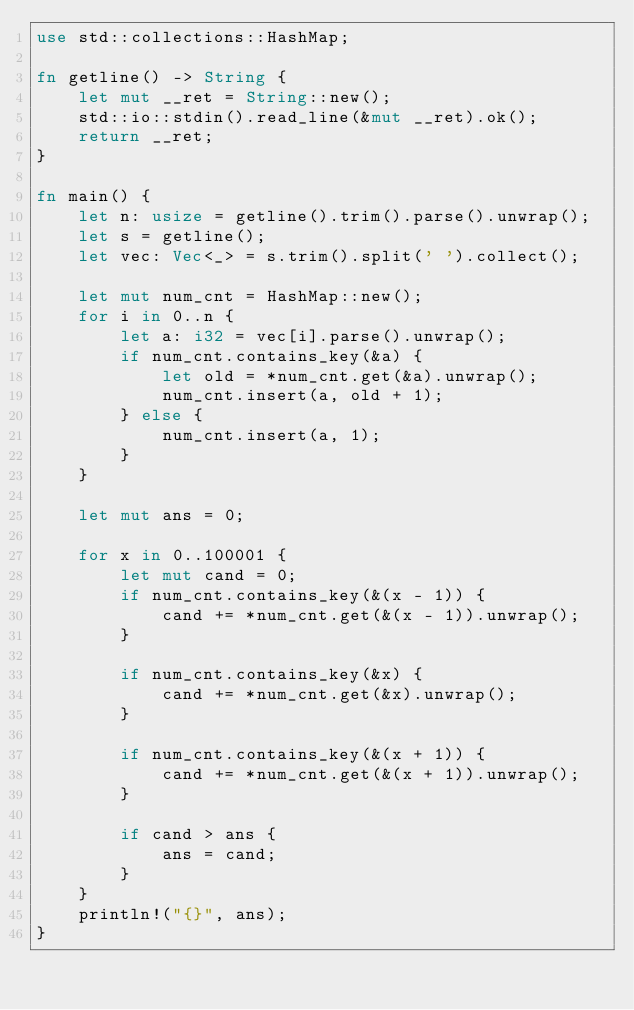<code> <loc_0><loc_0><loc_500><loc_500><_Rust_>use std::collections::HashMap;

fn getline() -> String {
    let mut __ret = String::new();
    std::io::stdin().read_line(&mut __ret).ok();
    return __ret;
}

fn main() {
    let n: usize = getline().trim().parse().unwrap();
    let s = getline();
    let vec: Vec<_> = s.trim().split(' ').collect();

    let mut num_cnt = HashMap::new();
    for i in 0..n {
        let a: i32 = vec[i].parse().unwrap();
        if num_cnt.contains_key(&a) {
            let old = *num_cnt.get(&a).unwrap();
            num_cnt.insert(a, old + 1);
        } else {
            num_cnt.insert(a, 1);
        }
    }

    let mut ans = 0;

    for x in 0..100001 {
        let mut cand = 0;
        if num_cnt.contains_key(&(x - 1)) {
            cand += *num_cnt.get(&(x - 1)).unwrap();
        }

        if num_cnt.contains_key(&x) {
            cand += *num_cnt.get(&x).unwrap();
        }

        if num_cnt.contains_key(&(x + 1)) {
            cand += *num_cnt.get(&(x + 1)).unwrap();
        }

        if cand > ans {
            ans = cand;
        }
    }
    println!("{}", ans);
}
</code> 